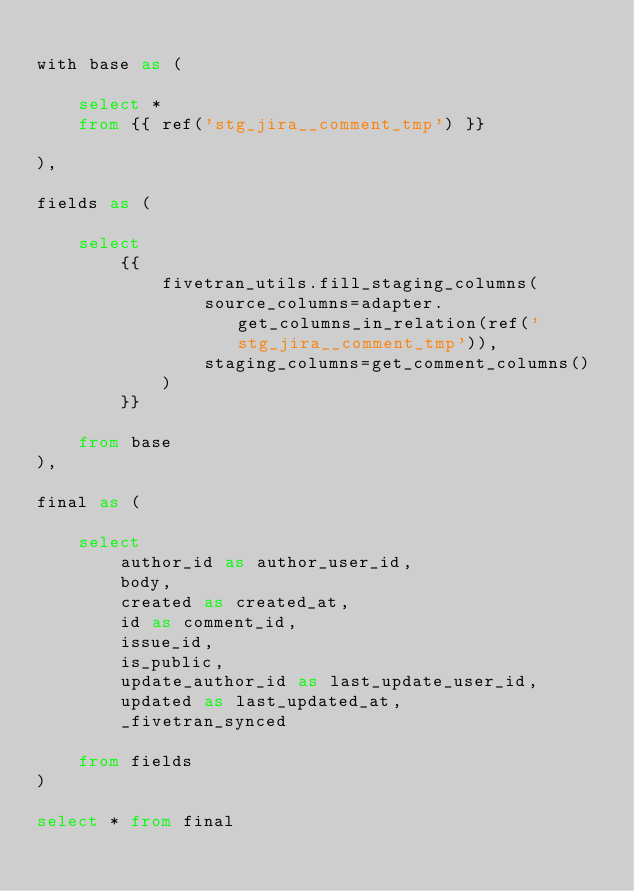Convert code to text. <code><loc_0><loc_0><loc_500><loc_500><_SQL_>
with base as (

    select * 
    from {{ ref('stg_jira__comment_tmp') }}

),

fields as (

    select
        {{
            fivetran_utils.fill_staging_columns(
                source_columns=adapter.get_columns_in_relation(ref('stg_jira__comment_tmp')),
                staging_columns=get_comment_columns()
            )
        }}
        
    from base
),

final as (
    
    select 
        author_id as author_user_id,
        body,
        created as created_at,
        id as comment_id,
        issue_id,
        is_public,
        update_author_id as last_update_user_id,
        updated as last_updated_at,
        _fivetran_synced

    from fields
)

select * from final</code> 